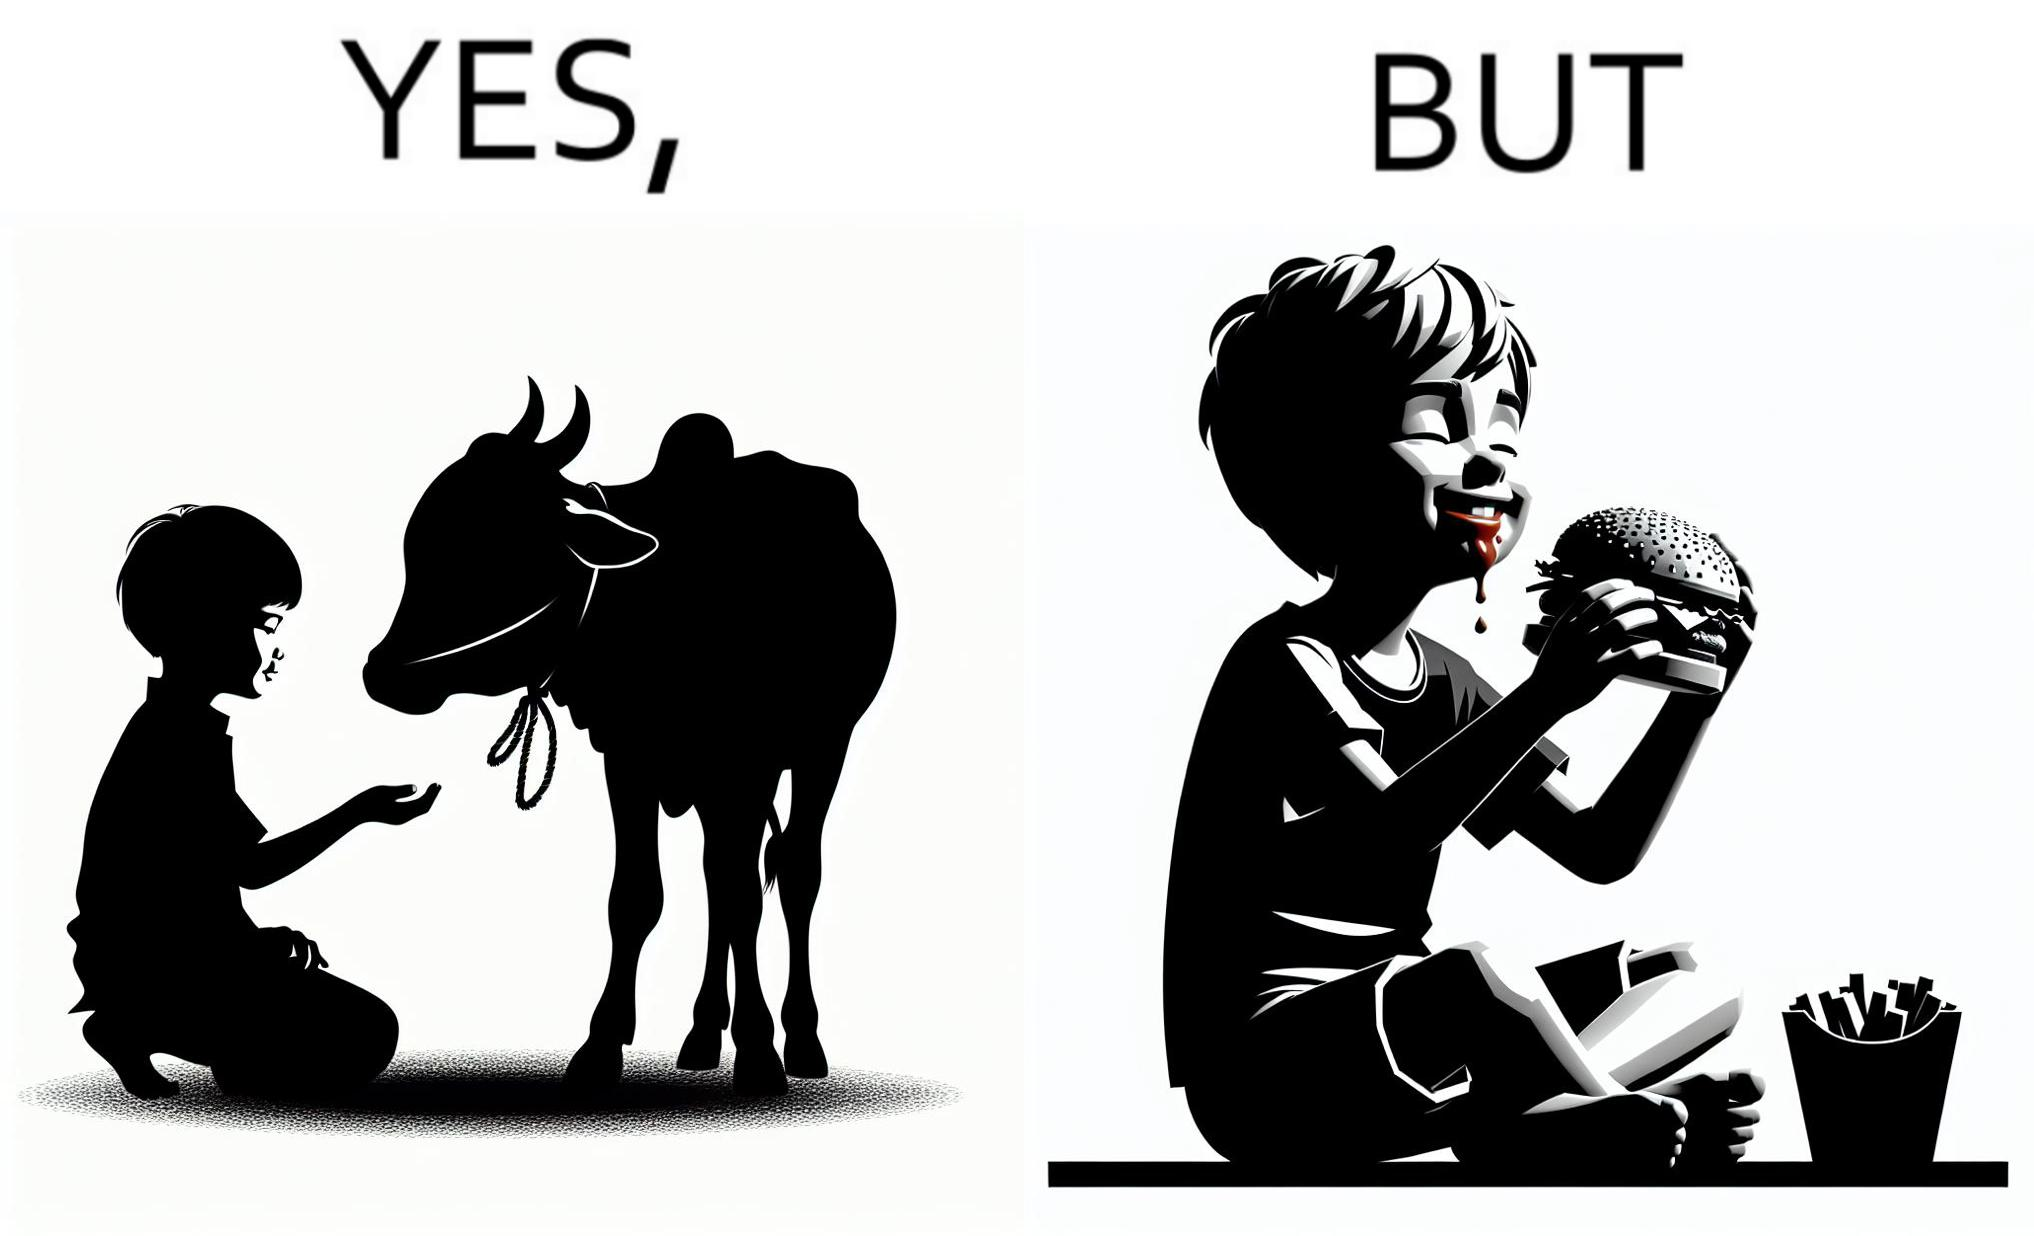Describe the contrast between the left and right parts of this image. In the left part of the image: A boy petting a cow In the right part of the image: A boy eating a hamburger 